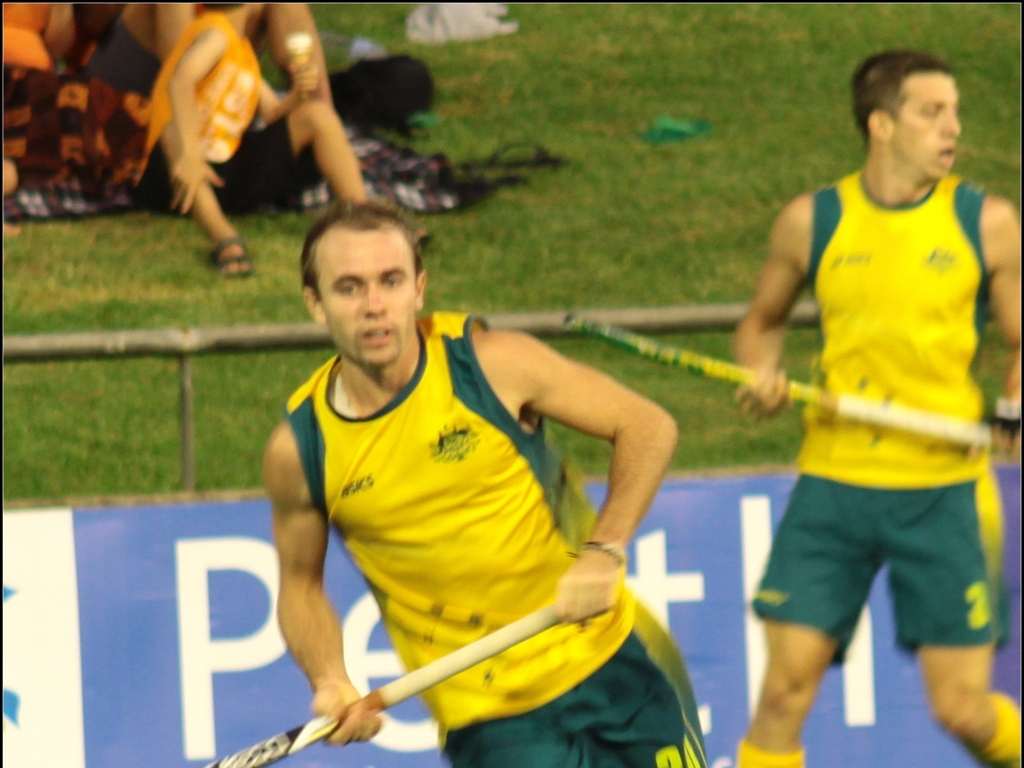How is the focus on the people in the foreground? The focus on the individuals in the foreground of the image is not clear. Due to the motion blur, details such as facial features, textures of the clothing, and even the object the person is holding, which appears to be a sports stick, are obscured, indicative of the camera capturing them in swift movement or not being correctly focused on these subjects at the time of shooting the photograph. 